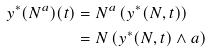<formula> <loc_0><loc_0><loc_500><loc_500>y ^ { * } ( N ^ { a } ) ( t ) & = N ^ { a } \left ( y ^ { * } ( N , t ) \right ) \\ & = N \left ( y ^ { * } ( N , t ) \wedge a \right )</formula> 